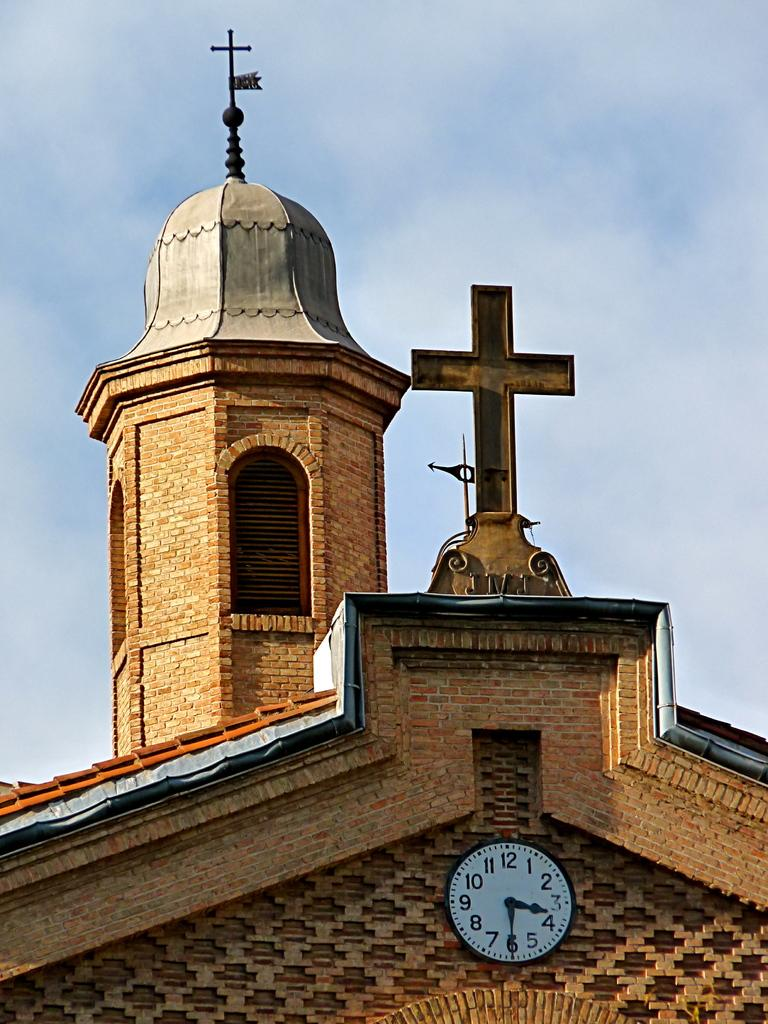<image>
Describe the image concisely. Church with a clock that has the hands on the 3 and 6. 